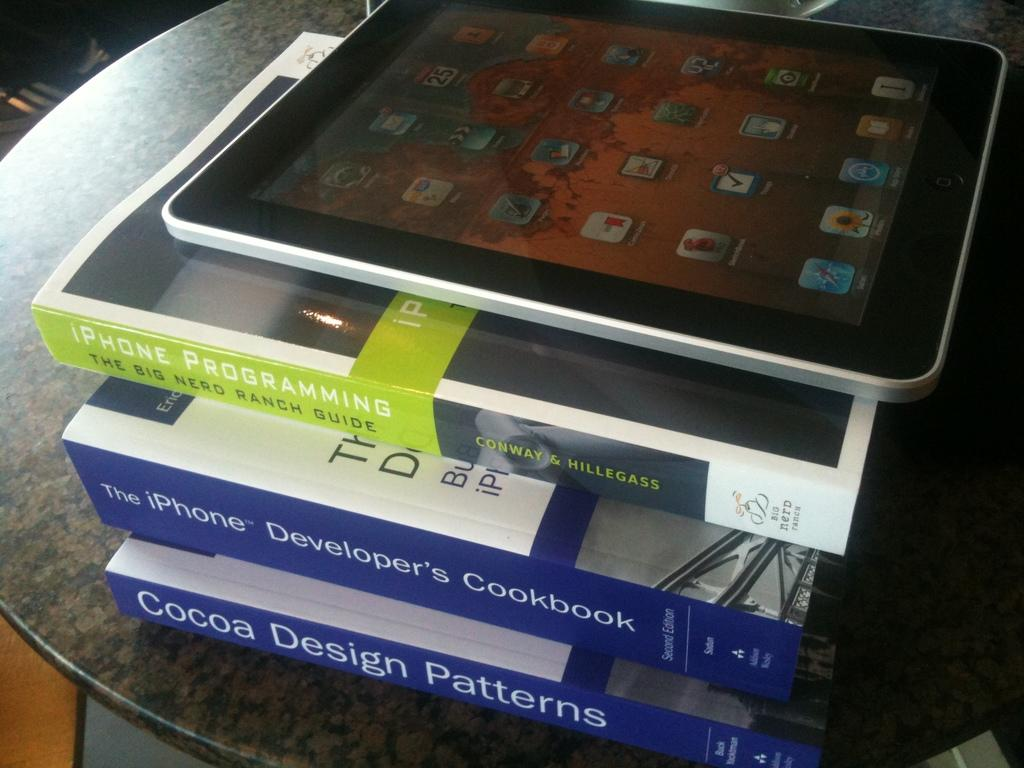<image>
Relay a brief, clear account of the picture shown. In addition to the iPad, 3 books, "iPhone Programming", "The iPhone Developer's Cookbook", and "Cocoa Design Patterns" sat on the table. 